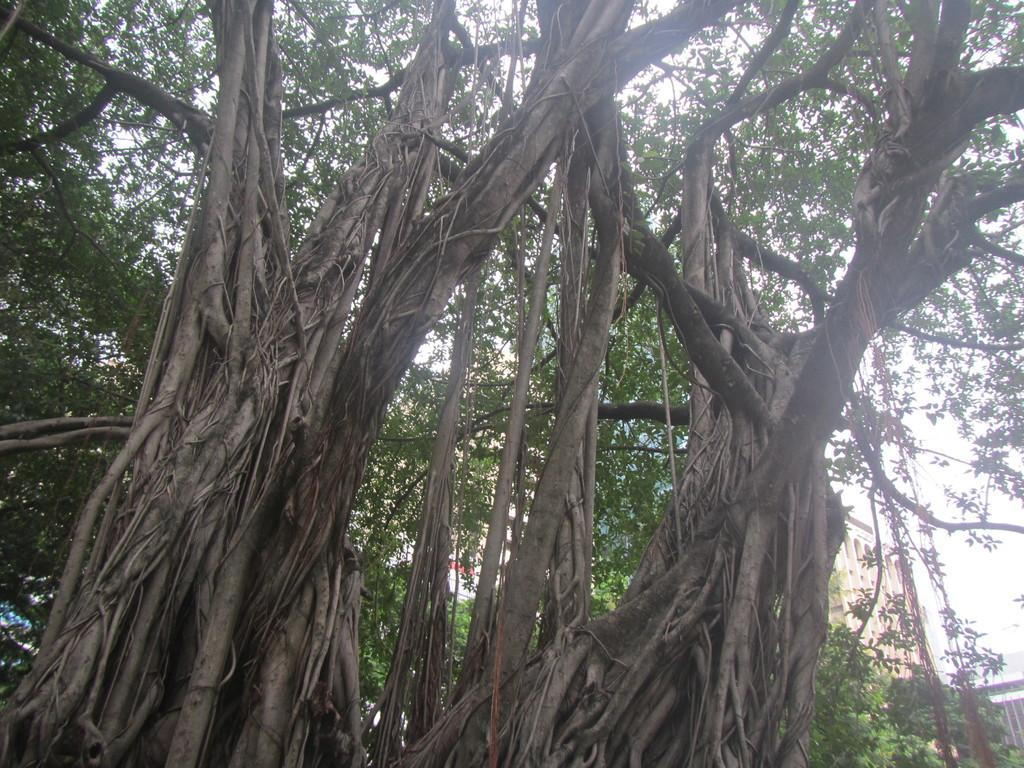What type of vegetation can be seen in the image? There are trees in the image. Where are the buildings located in the image? There are two buildings on the right side of the image. What type of channel can be seen in the image? There is no channel present in the image; it features trees and buildings. How does the plough interact with the trees in the image? There is no plough present in the image, so it cannot interact with the trees. 